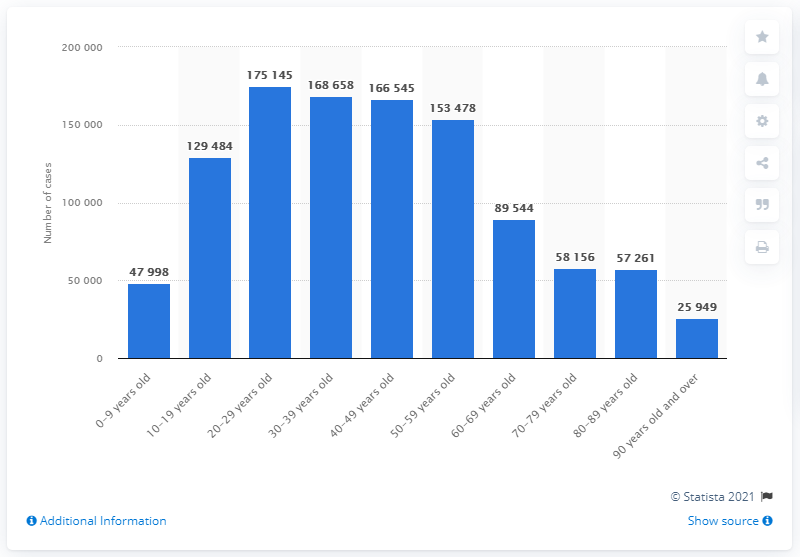Draw attention to some important aspects in this diagram. In the 30-39 age group, a total of 168,658 individuals tested positive for COVID-19. During the reporting period between the ages of 20 and 29 years old, a total of 175,145 COVID-19 cases were reported. 